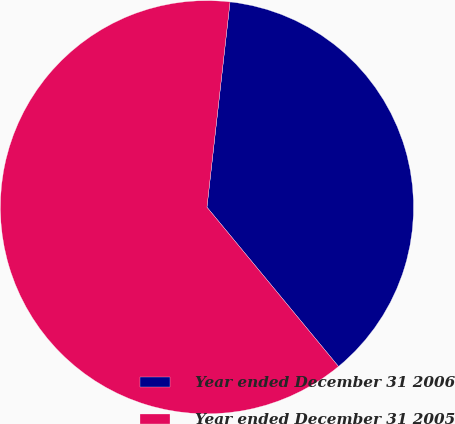Convert chart. <chart><loc_0><loc_0><loc_500><loc_500><pie_chart><fcel>Year ended December 31 2006<fcel>Year ended December 31 2005<nl><fcel>37.23%<fcel>62.77%<nl></chart> 